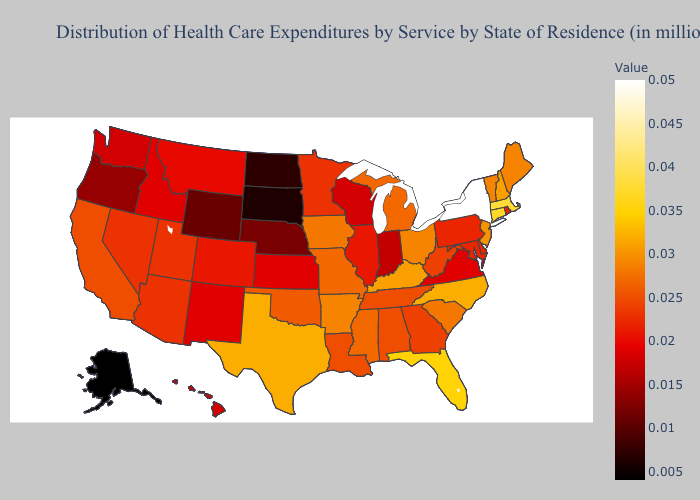Does Pennsylvania have the lowest value in the Northeast?
Give a very brief answer. Yes. Which states have the lowest value in the West?
Quick response, please. Alaska. Among the states that border Delaware , which have the highest value?
Short answer required. New Jersey. Does Ohio have the highest value in the MidWest?
Be succinct. Yes. Among the states that border Louisiana , does Texas have the highest value?
Short answer required. Yes. Does Vermont have the highest value in the Northeast?
Concise answer only. No. 